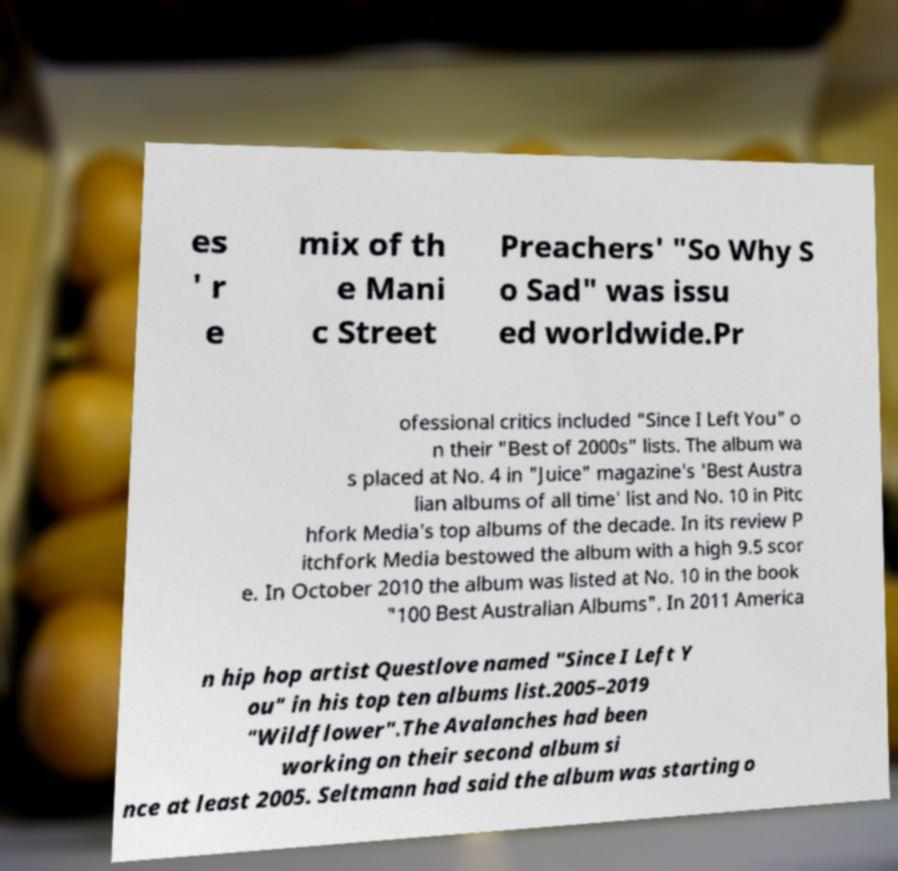Please read and relay the text visible in this image. What does it say? es ' r e mix of th e Mani c Street Preachers' "So Why S o Sad" was issu ed worldwide.Pr ofessional critics included "Since I Left You" o n their "Best of 2000s" lists. The album wa s placed at No. 4 in "Juice" magazine's 'Best Austra lian albums of all time' list and No. 10 in Pitc hfork Media's top albums of the decade. In its review P itchfork Media bestowed the album with a high 9.5 scor e. In October 2010 the album was listed at No. 10 in the book "100 Best Australian Albums". In 2011 America n hip hop artist Questlove named "Since I Left Y ou" in his top ten albums list.2005–2019 "Wildflower".The Avalanches had been working on their second album si nce at least 2005. Seltmann had said the album was starting o 